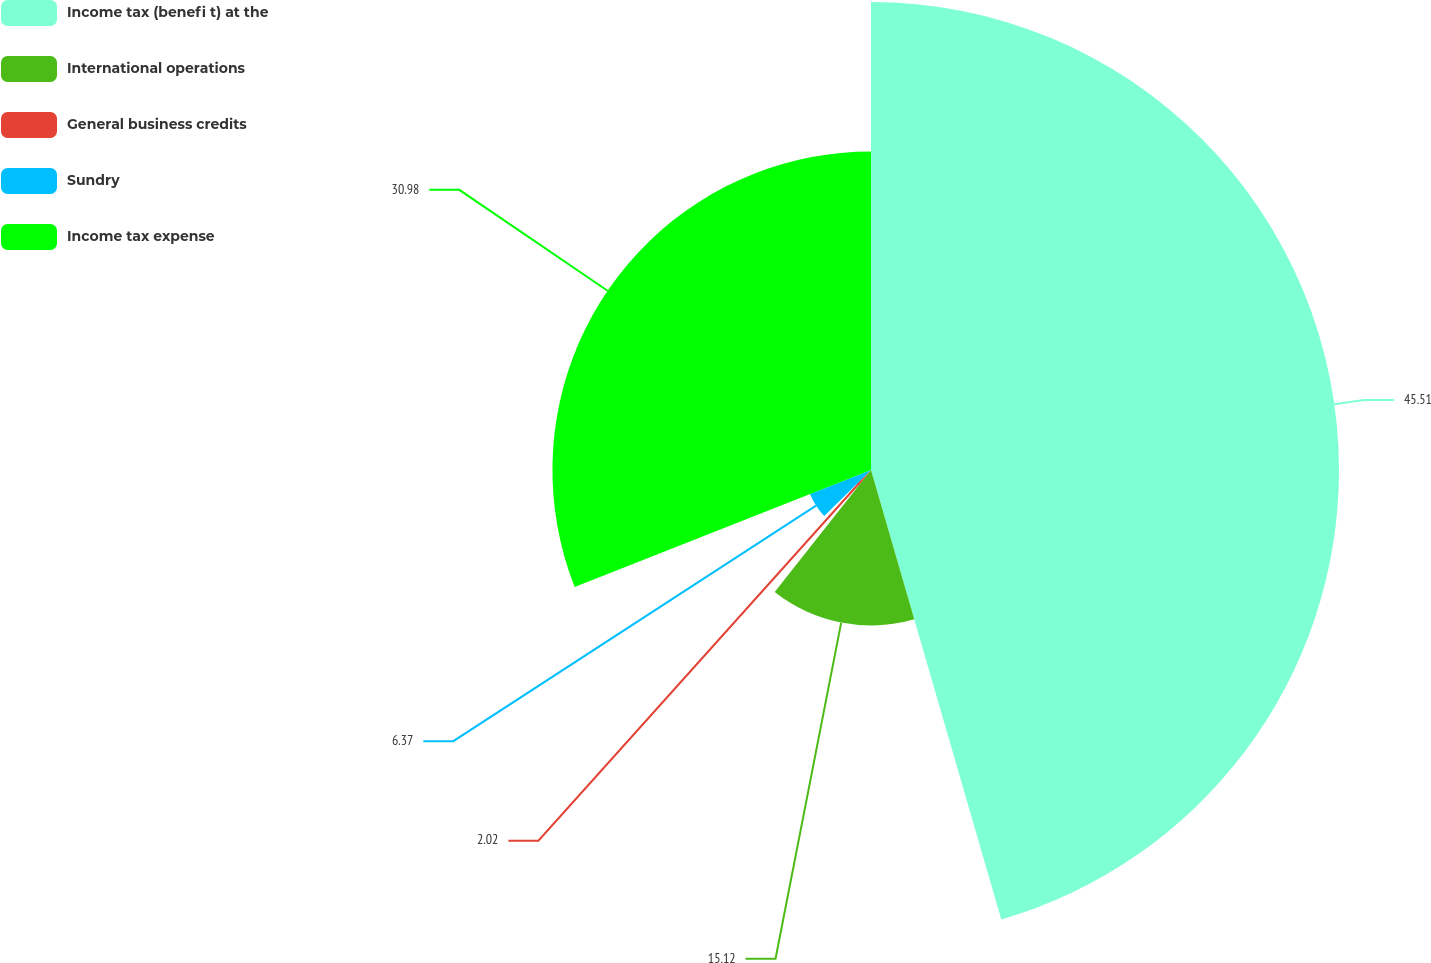Convert chart. <chart><loc_0><loc_0><loc_500><loc_500><pie_chart><fcel>Income tax (benefi t) at the<fcel>International operations<fcel>General business credits<fcel>Sundry<fcel>Income tax expense<nl><fcel>45.51%<fcel>15.12%<fcel>2.02%<fcel>6.37%<fcel>30.98%<nl></chart> 